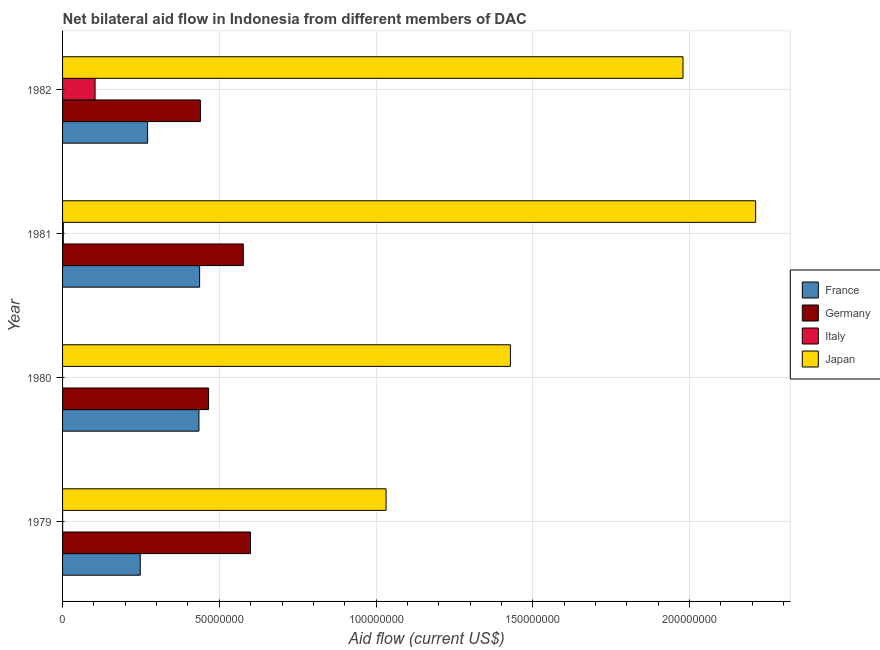How many different coloured bars are there?
Keep it short and to the point. 4. How many groups of bars are there?
Your answer should be very brief. 4. Are the number of bars per tick equal to the number of legend labels?
Provide a succinct answer. No. Are the number of bars on each tick of the Y-axis equal?
Your response must be concise. No. How many bars are there on the 2nd tick from the top?
Provide a short and direct response. 4. How many bars are there on the 3rd tick from the bottom?
Ensure brevity in your answer.  4. What is the label of the 4th group of bars from the top?
Offer a terse response. 1979. What is the amount of aid given by germany in 1981?
Your answer should be very brief. 5.76e+07. Across all years, what is the maximum amount of aid given by france?
Provide a succinct answer. 4.37e+07. Across all years, what is the minimum amount of aid given by germany?
Your answer should be compact. 4.40e+07. In which year was the amount of aid given by germany maximum?
Keep it short and to the point. 1979. What is the total amount of aid given by germany in the graph?
Offer a very short reply. 2.08e+08. What is the difference between the amount of aid given by japan in 1980 and that in 1982?
Your answer should be very brief. -5.51e+07. What is the difference between the amount of aid given by germany in 1982 and the amount of aid given by france in 1979?
Your response must be concise. 1.92e+07. What is the average amount of aid given by germany per year?
Your answer should be very brief. 5.20e+07. In the year 1982, what is the difference between the amount of aid given by japan and amount of aid given by france?
Keep it short and to the point. 1.71e+08. What is the ratio of the amount of aid given by france in 1980 to that in 1981?
Give a very brief answer. 0.99. Is the amount of aid given by france in 1979 less than that in 1981?
Provide a short and direct response. Yes. What is the difference between the highest and the second highest amount of aid given by italy?
Provide a short and direct response. 1.01e+07. What is the difference between the highest and the lowest amount of aid given by france?
Your answer should be compact. 1.89e+07. Is it the case that in every year, the sum of the amount of aid given by italy and amount of aid given by germany is greater than the sum of amount of aid given by france and amount of aid given by japan?
Offer a terse response. No. Is it the case that in every year, the sum of the amount of aid given by france and amount of aid given by germany is greater than the amount of aid given by italy?
Ensure brevity in your answer.  Yes. How many bars are there?
Your response must be concise. 15. Are all the bars in the graph horizontal?
Provide a succinct answer. Yes. How many years are there in the graph?
Provide a succinct answer. 4. What is the difference between two consecutive major ticks on the X-axis?
Your answer should be very brief. 5.00e+07. Are the values on the major ticks of X-axis written in scientific E-notation?
Make the answer very short. No. Does the graph contain grids?
Your response must be concise. Yes. Where does the legend appear in the graph?
Keep it short and to the point. Center right. How are the legend labels stacked?
Keep it short and to the point. Vertical. What is the title of the graph?
Offer a terse response. Net bilateral aid flow in Indonesia from different members of DAC. What is the label or title of the Y-axis?
Keep it short and to the point. Year. What is the Aid flow (current US$) of France in 1979?
Provide a short and direct response. 2.48e+07. What is the Aid flow (current US$) in Germany in 1979?
Your response must be concise. 6.00e+07. What is the Aid flow (current US$) of Japan in 1979?
Provide a short and direct response. 1.03e+08. What is the Aid flow (current US$) of France in 1980?
Provide a short and direct response. 4.35e+07. What is the Aid flow (current US$) of Germany in 1980?
Offer a very short reply. 4.66e+07. What is the Aid flow (current US$) of Japan in 1980?
Offer a terse response. 1.43e+08. What is the Aid flow (current US$) in France in 1981?
Provide a short and direct response. 4.37e+07. What is the Aid flow (current US$) of Germany in 1981?
Offer a terse response. 5.76e+07. What is the Aid flow (current US$) of Japan in 1981?
Ensure brevity in your answer.  2.21e+08. What is the Aid flow (current US$) of France in 1982?
Your answer should be very brief. 2.71e+07. What is the Aid flow (current US$) in Germany in 1982?
Your answer should be compact. 4.40e+07. What is the Aid flow (current US$) of Italy in 1982?
Your answer should be compact. 1.04e+07. What is the Aid flow (current US$) of Japan in 1982?
Make the answer very short. 1.98e+08. Across all years, what is the maximum Aid flow (current US$) in France?
Your answer should be compact. 4.37e+07. Across all years, what is the maximum Aid flow (current US$) in Germany?
Your answer should be compact. 6.00e+07. Across all years, what is the maximum Aid flow (current US$) of Italy?
Your answer should be very brief. 1.04e+07. Across all years, what is the maximum Aid flow (current US$) in Japan?
Provide a short and direct response. 2.21e+08. Across all years, what is the minimum Aid flow (current US$) in France?
Keep it short and to the point. 2.48e+07. Across all years, what is the minimum Aid flow (current US$) in Germany?
Ensure brevity in your answer.  4.40e+07. Across all years, what is the minimum Aid flow (current US$) of Italy?
Your answer should be very brief. 0. Across all years, what is the minimum Aid flow (current US$) of Japan?
Your response must be concise. 1.03e+08. What is the total Aid flow (current US$) in France in the graph?
Ensure brevity in your answer.  1.39e+08. What is the total Aid flow (current US$) of Germany in the graph?
Your response must be concise. 2.08e+08. What is the total Aid flow (current US$) in Italy in the graph?
Your answer should be compact. 1.06e+07. What is the total Aid flow (current US$) of Japan in the graph?
Provide a succinct answer. 6.65e+08. What is the difference between the Aid flow (current US$) of France in 1979 and that in 1980?
Provide a short and direct response. -1.87e+07. What is the difference between the Aid flow (current US$) in Germany in 1979 and that in 1980?
Provide a succinct answer. 1.34e+07. What is the difference between the Aid flow (current US$) of Japan in 1979 and that in 1980?
Give a very brief answer. -3.97e+07. What is the difference between the Aid flow (current US$) of France in 1979 and that in 1981?
Make the answer very short. -1.89e+07. What is the difference between the Aid flow (current US$) of Germany in 1979 and that in 1981?
Provide a succinct answer. 2.30e+06. What is the difference between the Aid flow (current US$) in Italy in 1979 and that in 1981?
Give a very brief answer. -2.20e+05. What is the difference between the Aid flow (current US$) of Japan in 1979 and that in 1981?
Your answer should be very brief. -1.18e+08. What is the difference between the Aid flow (current US$) in France in 1979 and that in 1982?
Ensure brevity in your answer.  -2.35e+06. What is the difference between the Aid flow (current US$) in Germany in 1979 and that in 1982?
Offer a terse response. 1.60e+07. What is the difference between the Aid flow (current US$) of Italy in 1979 and that in 1982?
Ensure brevity in your answer.  -1.04e+07. What is the difference between the Aid flow (current US$) in Japan in 1979 and that in 1982?
Make the answer very short. -9.47e+07. What is the difference between the Aid flow (current US$) in Germany in 1980 and that in 1981?
Make the answer very short. -1.11e+07. What is the difference between the Aid flow (current US$) of Japan in 1980 and that in 1981?
Ensure brevity in your answer.  -7.82e+07. What is the difference between the Aid flow (current US$) in France in 1980 and that in 1982?
Make the answer very short. 1.64e+07. What is the difference between the Aid flow (current US$) in Germany in 1980 and that in 1982?
Offer a terse response. 2.61e+06. What is the difference between the Aid flow (current US$) of Japan in 1980 and that in 1982?
Offer a terse response. -5.51e+07. What is the difference between the Aid flow (current US$) in France in 1981 and that in 1982?
Make the answer very short. 1.66e+07. What is the difference between the Aid flow (current US$) of Germany in 1981 and that in 1982?
Your response must be concise. 1.37e+07. What is the difference between the Aid flow (current US$) of Italy in 1981 and that in 1982?
Provide a short and direct response. -1.01e+07. What is the difference between the Aid flow (current US$) of Japan in 1981 and that in 1982?
Provide a short and direct response. 2.32e+07. What is the difference between the Aid flow (current US$) of France in 1979 and the Aid flow (current US$) of Germany in 1980?
Provide a succinct answer. -2.18e+07. What is the difference between the Aid flow (current US$) of France in 1979 and the Aid flow (current US$) of Japan in 1980?
Offer a terse response. -1.18e+08. What is the difference between the Aid flow (current US$) of Germany in 1979 and the Aid flow (current US$) of Japan in 1980?
Ensure brevity in your answer.  -8.29e+07. What is the difference between the Aid flow (current US$) of Italy in 1979 and the Aid flow (current US$) of Japan in 1980?
Your answer should be compact. -1.43e+08. What is the difference between the Aid flow (current US$) of France in 1979 and the Aid flow (current US$) of Germany in 1981?
Ensure brevity in your answer.  -3.29e+07. What is the difference between the Aid flow (current US$) in France in 1979 and the Aid flow (current US$) in Italy in 1981?
Offer a very short reply. 2.45e+07. What is the difference between the Aid flow (current US$) in France in 1979 and the Aid flow (current US$) in Japan in 1981?
Your answer should be very brief. -1.96e+08. What is the difference between the Aid flow (current US$) of Germany in 1979 and the Aid flow (current US$) of Italy in 1981?
Offer a very short reply. 5.97e+07. What is the difference between the Aid flow (current US$) of Germany in 1979 and the Aid flow (current US$) of Japan in 1981?
Your answer should be very brief. -1.61e+08. What is the difference between the Aid flow (current US$) in Italy in 1979 and the Aid flow (current US$) in Japan in 1981?
Offer a very short reply. -2.21e+08. What is the difference between the Aid flow (current US$) of France in 1979 and the Aid flow (current US$) of Germany in 1982?
Keep it short and to the point. -1.92e+07. What is the difference between the Aid flow (current US$) in France in 1979 and the Aid flow (current US$) in Italy in 1982?
Provide a succinct answer. 1.44e+07. What is the difference between the Aid flow (current US$) of France in 1979 and the Aid flow (current US$) of Japan in 1982?
Your answer should be compact. -1.73e+08. What is the difference between the Aid flow (current US$) of Germany in 1979 and the Aid flow (current US$) of Italy in 1982?
Give a very brief answer. 4.96e+07. What is the difference between the Aid flow (current US$) of Germany in 1979 and the Aid flow (current US$) of Japan in 1982?
Offer a very short reply. -1.38e+08. What is the difference between the Aid flow (current US$) of Italy in 1979 and the Aid flow (current US$) of Japan in 1982?
Provide a short and direct response. -1.98e+08. What is the difference between the Aid flow (current US$) of France in 1980 and the Aid flow (current US$) of Germany in 1981?
Your answer should be compact. -1.42e+07. What is the difference between the Aid flow (current US$) of France in 1980 and the Aid flow (current US$) of Italy in 1981?
Ensure brevity in your answer.  4.33e+07. What is the difference between the Aid flow (current US$) of France in 1980 and the Aid flow (current US$) of Japan in 1981?
Provide a succinct answer. -1.78e+08. What is the difference between the Aid flow (current US$) in Germany in 1980 and the Aid flow (current US$) in Italy in 1981?
Your response must be concise. 4.63e+07. What is the difference between the Aid flow (current US$) in Germany in 1980 and the Aid flow (current US$) in Japan in 1981?
Provide a succinct answer. -1.75e+08. What is the difference between the Aid flow (current US$) in France in 1980 and the Aid flow (current US$) in Germany in 1982?
Your response must be concise. -4.70e+05. What is the difference between the Aid flow (current US$) of France in 1980 and the Aid flow (current US$) of Italy in 1982?
Make the answer very short. 3.31e+07. What is the difference between the Aid flow (current US$) in France in 1980 and the Aid flow (current US$) in Japan in 1982?
Offer a terse response. -1.54e+08. What is the difference between the Aid flow (current US$) of Germany in 1980 and the Aid flow (current US$) of Italy in 1982?
Give a very brief answer. 3.62e+07. What is the difference between the Aid flow (current US$) in Germany in 1980 and the Aid flow (current US$) in Japan in 1982?
Ensure brevity in your answer.  -1.51e+08. What is the difference between the Aid flow (current US$) of France in 1981 and the Aid flow (current US$) of Italy in 1982?
Keep it short and to the point. 3.34e+07. What is the difference between the Aid flow (current US$) of France in 1981 and the Aid flow (current US$) of Japan in 1982?
Provide a short and direct response. -1.54e+08. What is the difference between the Aid flow (current US$) of Germany in 1981 and the Aid flow (current US$) of Italy in 1982?
Keep it short and to the point. 4.73e+07. What is the difference between the Aid flow (current US$) of Germany in 1981 and the Aid flow (current US$) of Japan in 1982?
Offer a very short reply. -1.40e+08. What is the difference between the Aid flow (current US$) of Italy in 1981 and the Aid flow (current US$) of Japan in 1982?
Offer a very short reply. -1.98e+08. What is the average Aid flow (current US$) in France per year?
Ensure brevity in your answer.  3.48e+07. What is the average Aid flow (current US$) in Germany per year?
Your response must be concise. 5.20e+07. What is the average Aid flow (current US$) of Italy per year?
Your answer should be compact. 2.66e+06. What is the average Aid flow (current US$) in Japan per year?
Offer a very short reply. 1.66e+08. In the year 1979, what is the difference between the Aid flow (current US$) of France and Aid flow (current US$) of Germany?
Your response must be concise. -3.52e+07. In the year 1979, what is the difference between the Aid flow (current US$) in France and Aid flow (current US$) in Italy?
Offer a very short reply. 2.48e+07. In the year 1979, what is the difference between the Aid flow (current US$) of France and Aid flow (current US$) of Japan?
Provide a succinct answer. -7.84e+07. In the year 1979, what is the difference between the Aid flow (current US$) of Germany and Aid flow (current US$) of Italy?
Ensure brevity in your answer.  5.99e+07. In the year 1979, what is the difference between the Aid flow (current US$) of Germany and Aid flow (current US$) of Japan?
Give a very brief answer. -4.32e+07. In the year 1979, what is the difference between the Aid flow (current US$) in Italy and Aid flow (current US$) in Japan?
Make the answer very short. -1.03e+08. In the year 1980, what is the difference between the Aid flow (current US$) in France and Aid flow (current US$) in Germany?
Ensure brevity in your answer.  -3.08e+06. In the year 1980, what is the difference between the Aid flow (current US$) of France and Aid flow (current US$) of Japan?
Offer a very short reply. -9.94e+07. In the year 1980, what is the difference between the Aid flow (current US$) in Germany and Aid flow (current US$) in Japan?
Your response must be concise. -9.63e+07. In the year 1981, what is the difference between the Aid flow (current US$) in France and Aid flow (current US$) in Germany?
Your answer should be compact. -1.39e+07. In the year 1981, what is the difference between the Aid flow (current US$) of France and Aid flow (current US$) of Italy?
Your answer should be compact. 4.35e+07. In the year 1981, what is the difference between the Aid flow (current US$) of France and Aid flow (current US$) of Japan?
Provide a succinct answer. -1.77e+08. In the year 1981, what is the difference between the Aid flow (current US$) in Germany and Aid flow (current US$) in Italy?
Offer a terse response. 5.74e+07. In the year 1981, what is the difference between the Aid flow (current US$) of Germany and Aid flow (current US$) of Japan?
Your answer should be compact. -1.63e+08. In the year 1981, what is the difference between the Aid flow (current US$) in Italy and Aid flow (current US$) in Japan?
Give a very brief answer. -2.21e+08. In the year 1982, what is the difference between the Aid flow (current US$) in France and Aid flow (current US$) in Germany?
Provide a succinct answer. -1.68e+07. In the year 1982, what is the difference between the Aid flow (current US$) of France and Aid flow (current US$) of Italy?
Your answer should be compact. 1.68e+07. In the year 1982, what is the difference between the Aid flow (current US$) of France and Aid flow (current US$) of Japan?
Offer a very short reply. -1.71e+08. In the year 1982, what is the difference between the Aid flow (current US$) in Germany and Aid flow (current US$) in Italy?
Keep it short and to the point. 3.36e+07. In the year 1982, what is the difference between the Aid flow (current US$) of Germany and Aid flow (current US$) of Japan?
Give a very brief answer. -1.54e+08. In the year 1982, what is the difference between the Aid flow (current US$) of Italy and Aid flow (current US$) of Japan?
Your response must be concise. -1.88e+08. What is the ratio of the Aid flow (current US$) in France in 1979 to that in 1980?
Your response must be concise. 0.57. What is the ratio of the Aid flow (current US$) of Germany in 1979 to that in 1980?
Make the answer very short. 1.29. What is the ratio of the Aid flow (current US$) in Japan in 1979 to that in 1980?
Offer a very short reply. 0.72. What is the ratio of the Aid flow (current US$) of France in 1979 to that in 1981?
Provide a short and direct response. 0.57. What is the ratio of the Aid flow (current US$) of Germany in 1979 to that in 1981?
Offer a terse response. 1.04. What is the ratio of the Aid flow (current US$) in Italy in 1979 to that in 1981?
Your response must be concise. 0.08. What is the ratio of the Aid flow (current US$) in Japan in 1979 to that in 1981?
Offer a very short reply. 0.47. What is the ratio of the Aid flow (current US$) of France in 1979 to that in 1982?
Your answer should be very brief. 0.91. What is the ratio of the Aid flow (current US$) of Germany in 1979 to that in 1982?
Keep it short and to the point. 1.36. What is the ratio of the Aid flow (current US$) of Italy in 1979 to that in 1982?
Provide a succinct answer. 0. What is the ratio of the Aid flow (current US$) in Japan in 1979 to that in 1982?
Your response must be concise. 0.52. What is the ratio of the Aid flow (current US$) of France in 1980 to that in 1981?
Make the answer very short. 0.99. What is the ratio of the Aid flow (current US$) in Germany in 1980 to that in 1981?
Ensure brevity in your answer.  0.81. What is the ratio of the Aid flow (current US$) in Japan in 1980 to that in 1981?
Ensure brevity in your answer.  0.65. What is the ratio of the Aid flow (current US$) of France in 1980 to that in 1982?
Provide a succinct answer. 1.6. What is the ratio of the Aid flow (current US$) of Germany in 1980 to that in 1982?
Give a very brief answer. 1.06. What is the ratio of the Aid flow (current US$) of Japan in 1980 to that in 1982?
Offer a very short reply. 0.72. What is the ratio of the Aid flow (current US$) of France in 1981 to that in 1982?
Give a very brief answer. 1.61. What is the ratio of the Aid flow (current US$) in Germany in 1981 to that in 1982?
Your answer should be compact. 1.31. What is the ratio of the Aid flow (current US$) in Italy in 1981 to that in 1982?
Provide a succinct answer. 0.02. What is the ratio of the Aid flow (current US$) of Japan in 1981 to that in 1982?
Give a very brief answer. 1.12. What is the difference between the highest and the second highest Aid flow (current US$) in Germany?
Your answer should be very brief. 2.30e+06. What is the difference between the highest and the second highest Aid flow (current US$) in Italy?
Your response must be concise. 1.01e+07. What is the difference between the highest and the second highest Aid flow (current US$) of Japan?
Make the answer very short. 2.32e+07. What is the difference between the highest and the lowest Aid flow (current US$) of France?
Ensure brevity in your answer.  1.89e+07. What is the difference between the highest and the lowest Aid flow (current US$) in Germany?
Offer a very short reply. 1.60e+07. What is the difference between the highest and the lowest Aid flow (current US$) in Italy?
Make the answer very short. 1.04e+07. What is the difference between the highest and the lowest Aid flow (current US$) in Japan?
Keep it short and to the point. 1.18e+08. 